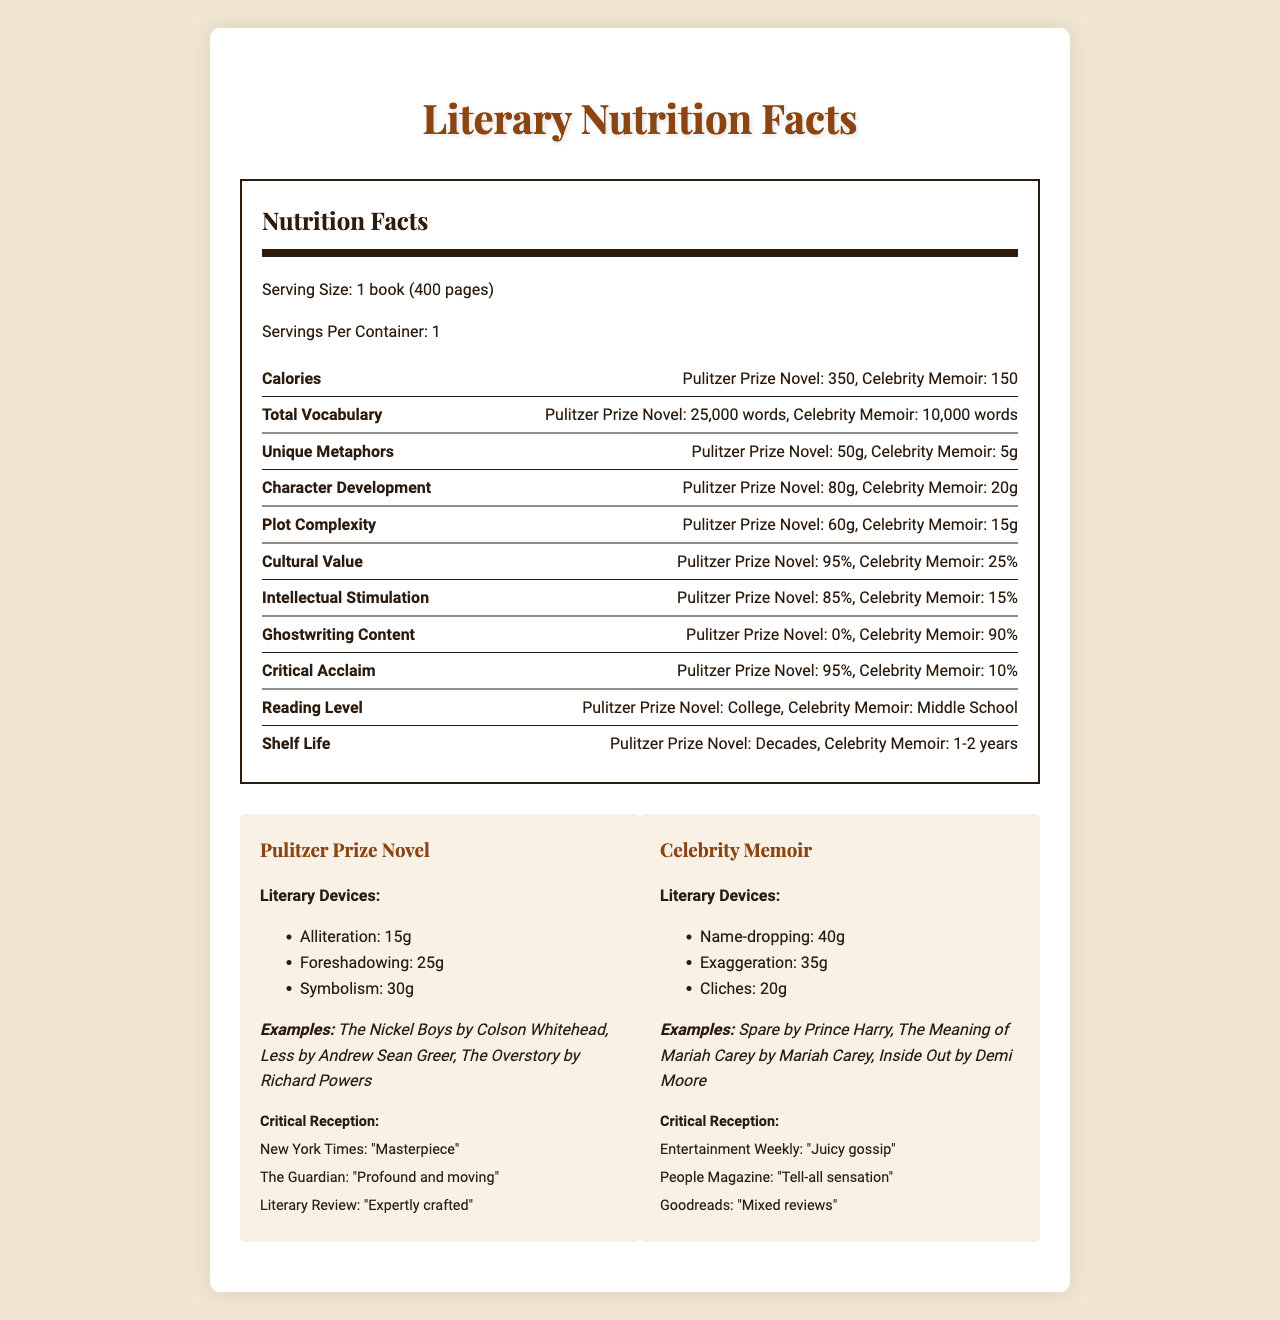what is the serving size of both types of books? The serving size mentioned for both Pulitzer Prize-winning novels and celebrity memoirs is 1 book, which is defined as 400 pages.
Answer: 1 book (400 pages) how many calories are in a Pulitzer Prize-winning novel? According to the nutrition facts, a Pulitzer Prize-winning novel contains 350 calories.
Answer: 350 calories how much character development is found in a Pulitzer Prize-winning novel vs. a celebrity memoir? The nutrition facts indicate that a Pulitzer Prize-winning novel has 80g of character development, while a celebrity memoir has 20g.
Answer: 80g vs. 20g how would you categorize the reading levels? The document specifies that Pulitzer Prize-winning novels have a college reading level, while celebrity memoirs have a middle school reading level.
Answer: Pulitzer Prize Novel: College, Celebrity Memoir: Middle School what percentage of ghostwriting content is in a celebrity memoir? The nutrition facts label states that ghostwritten content makes up 90% of celebrity memoirs.
Answer: 90% Which literary nutrient is most abundant in Pulitzer Prize-winning novels? A. Total Vocabulary B. Unique Metaphors C. Character Development Among the listed nutrients, character development is the most abundant in Pulitzer Prize-winning novels with 80g.
Answer: C. Character Development Which of the following critical reception quotes is associated with celebrity memoirs? i. "Masterpiece" ii. "Juicy gossip" iii. "Expertly crafted" "Juicy gossip" is a quote from Entertainment Weekly, which reviews celebrity memoirs.
Answer: ii. "Juicy gossip" Do Pulitzer Prize-winning novels have more cultural value than celebrity memoirs? The document indicates that Pulitzer Prize-winning novels have a cultural value of 95%, while celebrity memoirs have a cultural value of 25%.
Answer: Yes Describe the main idea of the document. This comprehensive comparison focuses on various metrics to showcase the higher literary and intellectual value attributed to Pulitzer Prize-winning novels compared to celebrity memoirs, which largely contain ghostwritten content and utilize simpler language and literary devices.
Answer: The document compares the nutritional value of Pulitzer Prize-winning novels to celebrity memoirs, analyzing various aspects such as total vocabulary, character development, intellectual stimulation, and cultural value. It also looks at literary devices and critical reception to highlight the differences in literary quality and impact. What are the specific examples mentioned for celebrity memoirs? These specific examples of celebrity memoirs are listed under the examples section in the document.
Answer: Spare by Prince Harry, The Meaning of Mariah Carey by Mariah Carey, Inside Out by Demi Moore Can we determine the exact price difference between Pulitzer Prize-winning novels and celebrity memoirs based on the document? The document does not provide any information about the price of the books, so the exact price difference cannot be determined from the given visual data.
Answer: Cannot be determined 